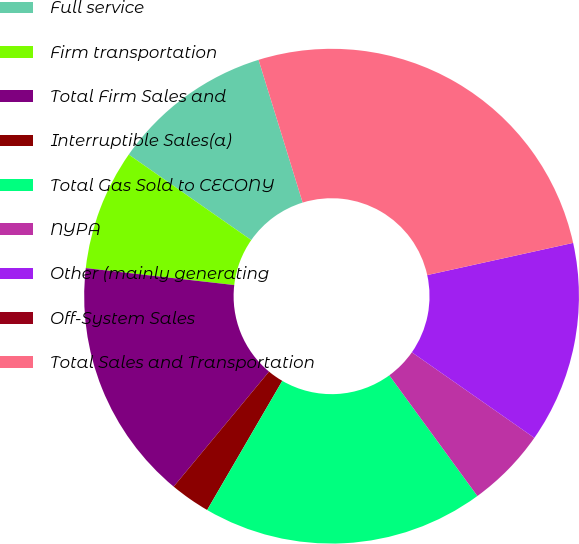Convert chart to OTSL. <chart><loc_0><loc_0><loc_500><loc_500><pie_chart><fcel>Full service<fcel>Firm transportation<fcel>Total Firm Sales and<fcel>Interruptible Sales(a)<fcel>Total Gas Sold to CECONY<fcel>NYPA<fcel>Other (mainly generating<fcel>Off-System Sales<fcel>Total Sales and Transportation<nl><fcel>10.53%<fcel>7.89%<fcel>15.79%<fcel>2.63%<fcel>18.42%<fcel>5.26%<fcel>13.16%<fcel>0.0%<fcel>26.31%<nl></chart> 